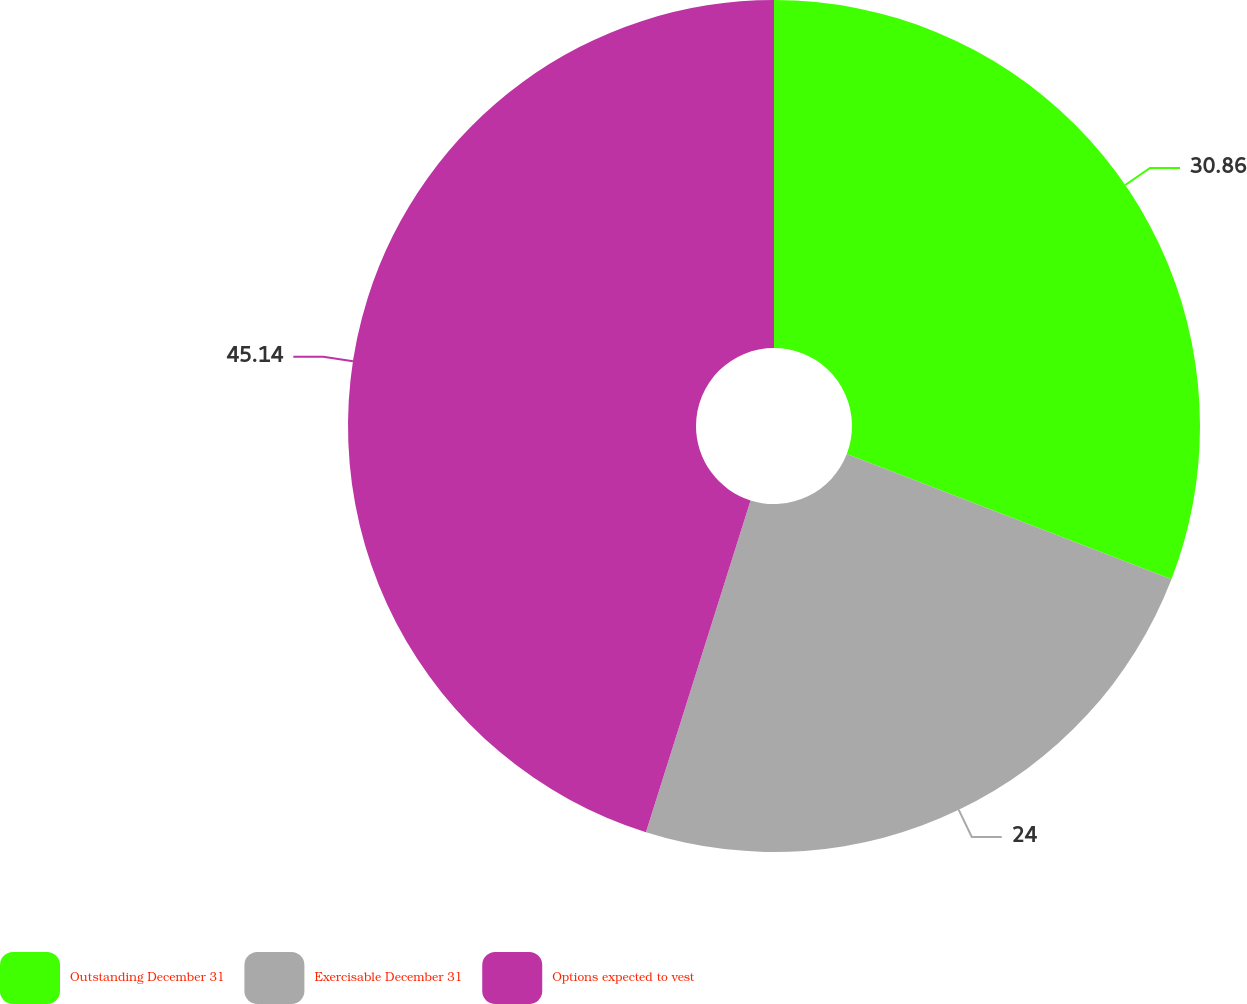Convert chart. <chart><loc_0><loc_0><loc_500><loc_500><pie_chart><fcel>Outstanding December 31<fcel>Exercisable December 31<fcel>Options expected to vest<nl><fcel>30.86%<fcel>24.0%<fcel>45.14%<nl></chart> 